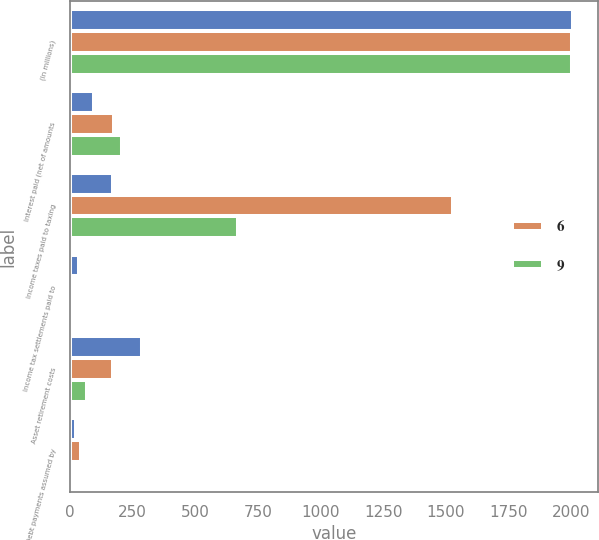<chart> <loc_0><loc_0><loc_500><loc_500><stacked_bar_chart><ecel><fcel>(In millions)<fcel>Interest paid (net of amounts<fcel>Income taxes paid to taxing<fcel>Income tax settlements paid to<fcel>Asset retirement costs<fcel>Debt payments assumed by<nl><fcel>nan<fcel>2006<fcel>96<fcel>171<fcel>35<fcel>286<fcel>24<nl><fcel>6<fcel>2005<fcel>174<fcel>1528<fcel>6<fcel>171<fcel>44<nl><fcel>9<fcel>2004<fcel>206<fcel>672<fcel>3<fcel>66<fcel>13<nl></chart> 